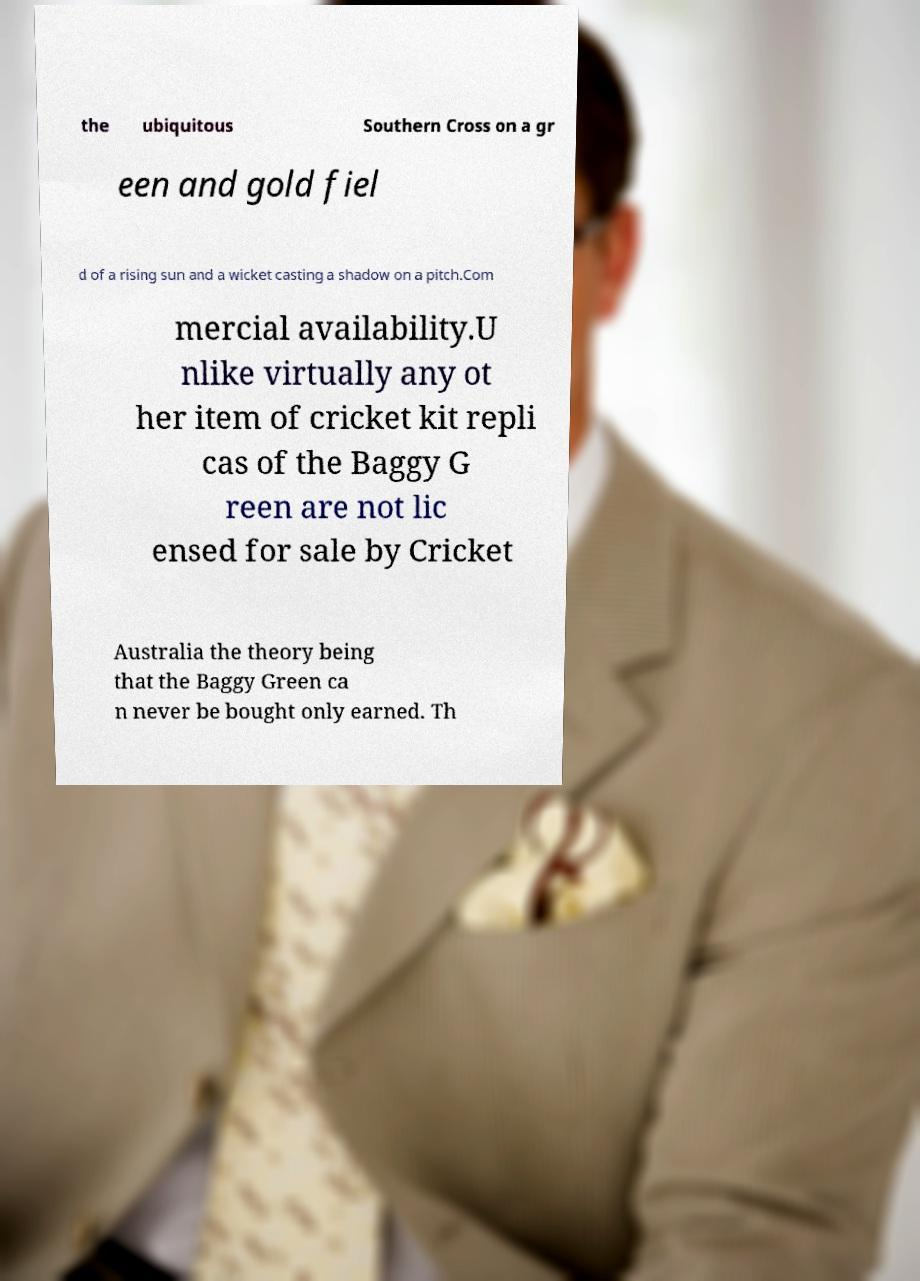I need the written content from this picture converted into text. Can you do that? the ubiquitous Southern Cross on a gr een and gold fiel d of a rising sun and a wicket casting a shadow on a pitch.Com mercial availability.U nlike virtually any ot her item of cricket kit repli cas of the Baggy G reen are not lic ensed for sale by Cricket Australia the theory being that the Baggy Green ca n never be bought only earned. Th 